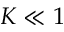Convert formula to latex. <formula><loc_0><loc_0><loc_500><loc_500>K \ll 1</formula> 